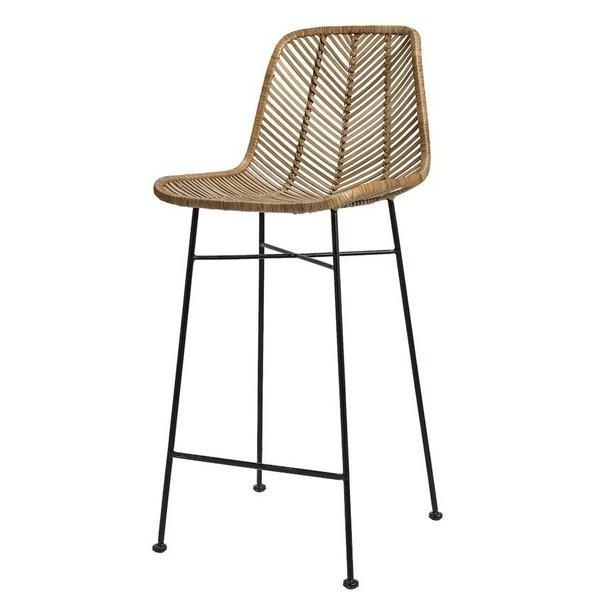Can you describe the style and design of this bar stool and how it might complement different interior spaces? The bar stool features a contemporary design with a touch of natural elegance, combining the sleekness of metal legs with the earthy, organic texture of woven rattan for the seat and backrest. This juxtaposition makes it incredibly versatile and able to complement a variety of interior styles. In a modern minimalist space, the stool adds a touch of warmth and natural beauty without overpowering the clean lines and simplicity. In a rustic or bohemian setting, it enhances the earthy, laid-back vibe while providing a functional piece of seating. Additionally, in an industrial loft with exposed metal and brick, the stool can soften the harshness of the materials with its organic texture, creating a balanced look. 